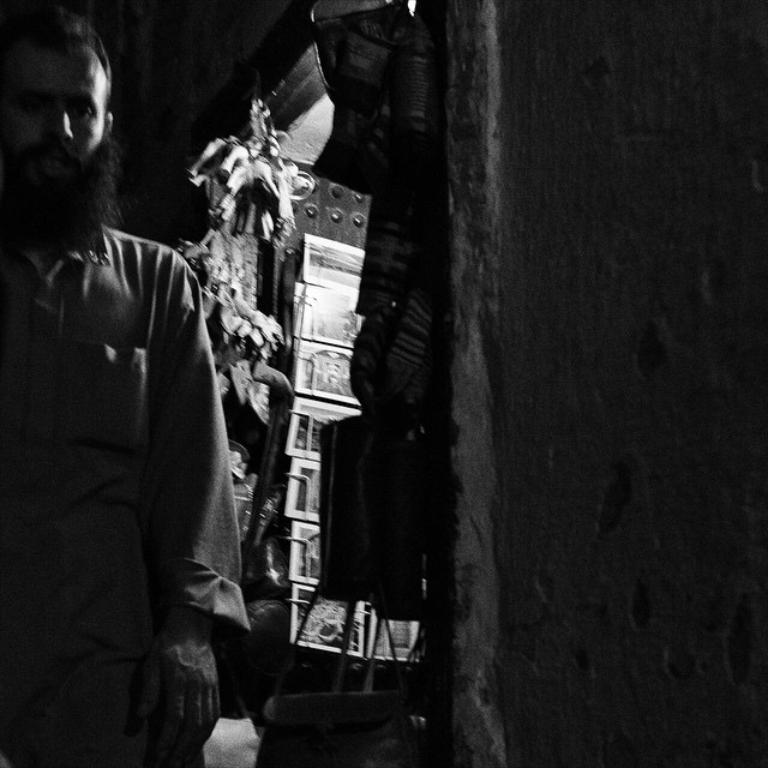In one or two sentences, can you explain what this image depicts? In this image there is a person truncated towards the left of the image, there are objects behind the person, there is a wall truncated towards the right of the image. 